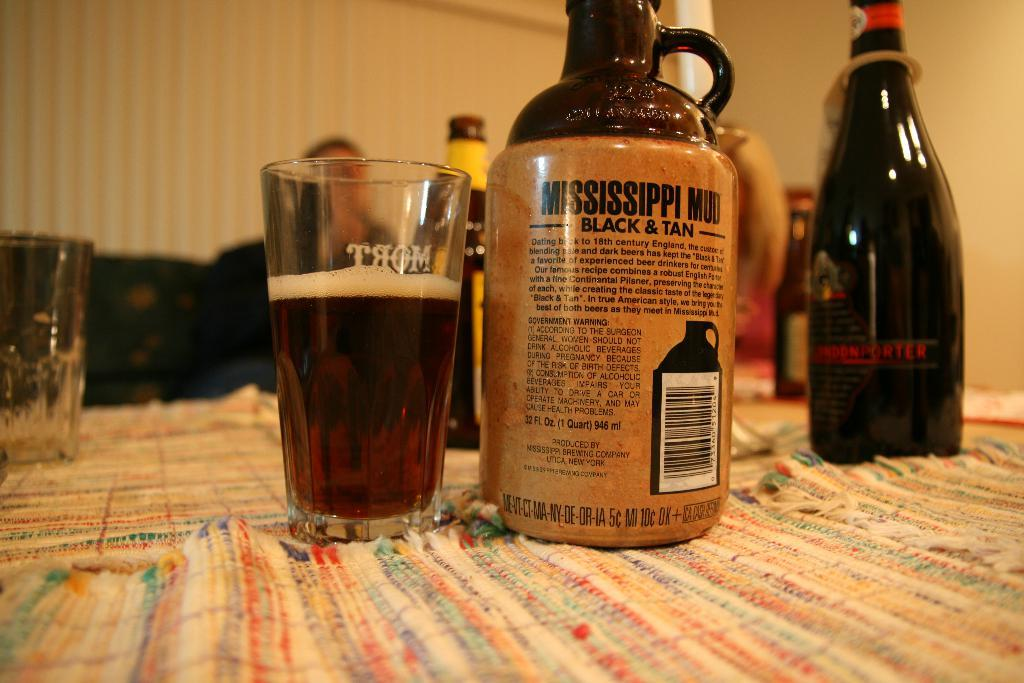<image>
Give a short and clear explanation of the subsequent image. A bottle of Mississippi Mud Black & Tan. 